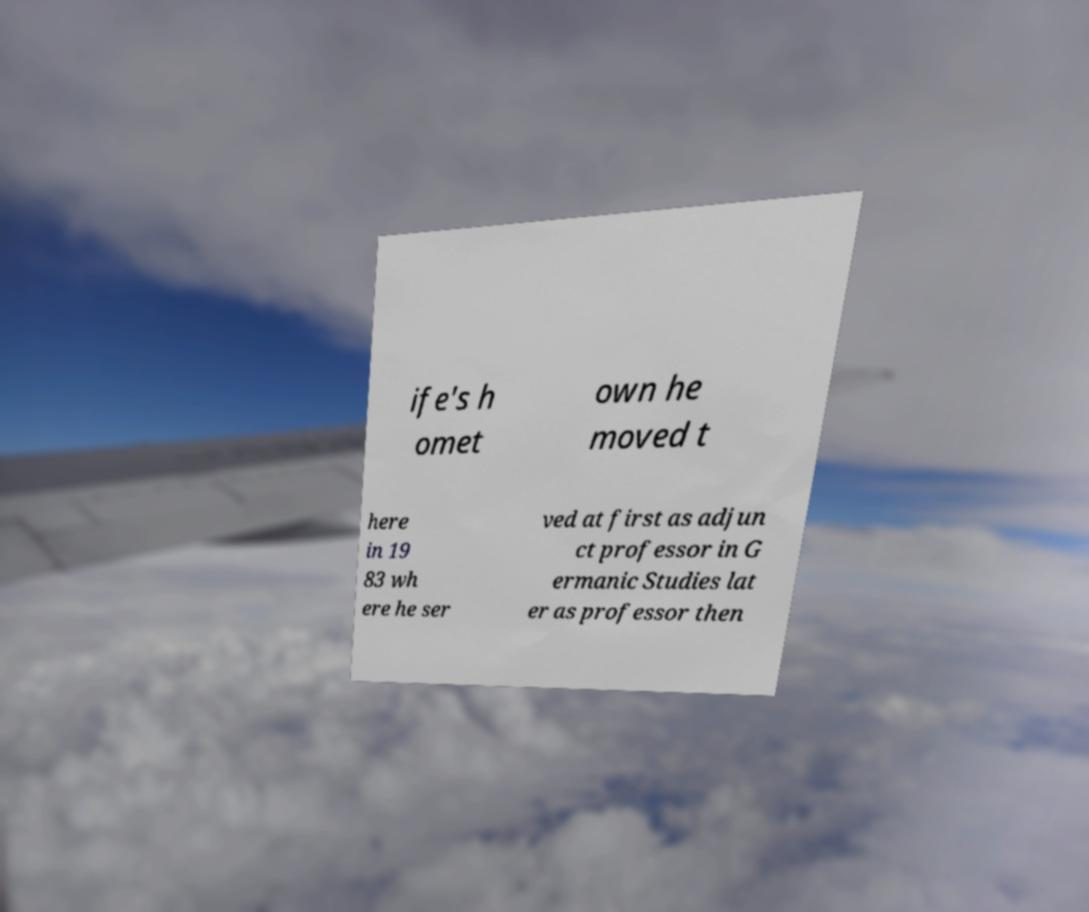Can you accurately transcribe the text from the provided image for me? ife's h omet own he moved t here in 19 83 wh ere he ser ved at first as adjun ct professor in G ermanic Studies lat er as professor then 